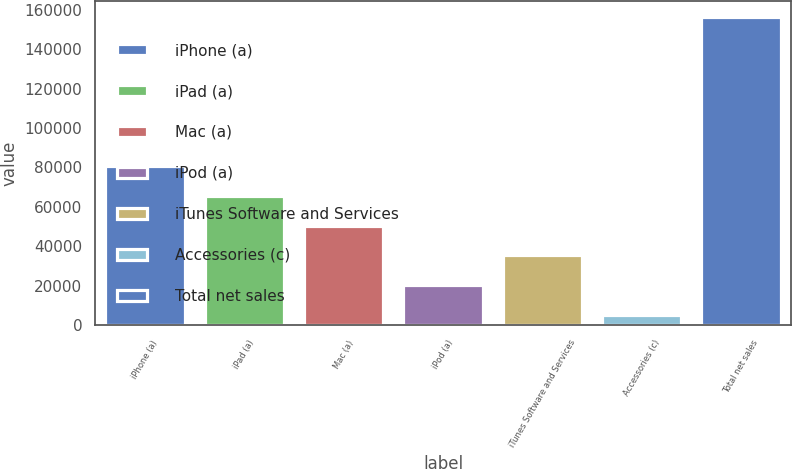Convert chart to OTSL. <chart><loc_0><loc_0><loc_500><loc_500><bar_chart><fcel>iPhone (a)<fcel>iPad (a)<fcel>Mac (a)<fcel>iPod (a)<fcel>iTunes Software and Services<fcel>Accessories (c)<fcel>Total net sales<nl><fcel>80826.5<fcel>65690.2<fcel>50553.9<fcel>20281.3<fcel>35417.6<fcel>5145<fcel>156508<nl></chart> 